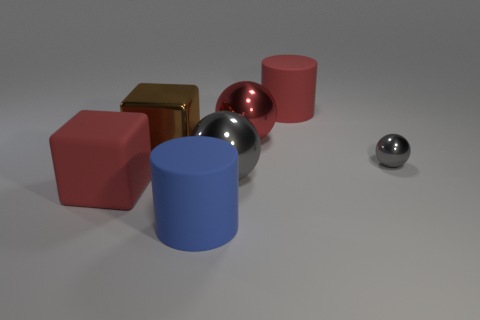There is a cylinder that is left of the red rubber object that is on the right side of the large red object in front of the tiny gray ball; what color is it?
Ensure brevity in your answer.  Blue. Is the shape of the red rubber object that is behind the tiny gray metal thing the same as  the small thing?
Keep it short and to the point. No. What number of big blue matte cylinders are there?
Provide a short and direct response. 1. What number of matte objects have the same size as the blue rubber cylinder?
Your answer should be compact. 2. What is the red cylinder made of?
Keep it short and to the point. Rubber. Does the large metal cube have the same color as the big metal sphere in front of the red ball?
Your answer should be compact. No. Are there any other things that have the same size as the rubber block?
Your response must be concise. Yes. There is a thing that is behind the tiny gray sphere and to the left of the large gray metallic object; what is its size?
Ensure brevity in your answer.  Large. There is a big brown thing that is made of the same material as the red sphere; what shape is it?
Offer a very short reply. Cube. Is the big red ball made of the same material as the large brown thing on the left side of the tiny object?
Ensure brevity in your answer.  Yes. 